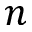<formula> <loc_0><loc_0><loc_500><loc_500>n</formula> 